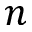<formula> <loc_0><loc_0><loc_500><loc_500>n</formula> 